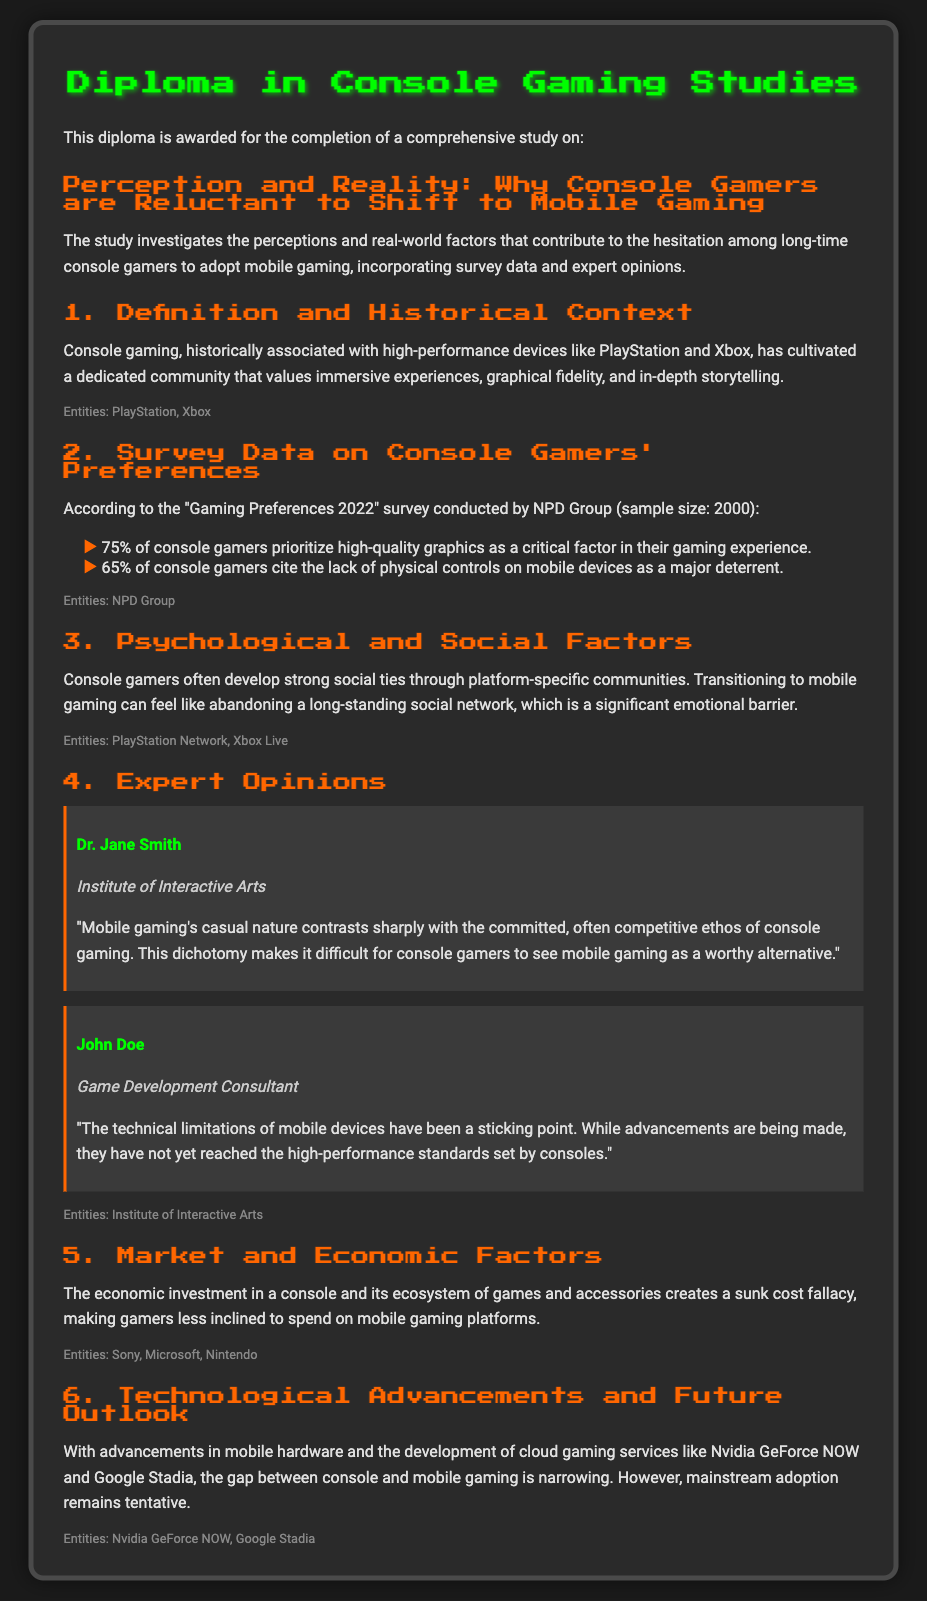what percentage of console gamers prioritize high-quality graphics? The survey data indicates that 75% of console gamers prioritize high-quality graphics as a critical factor in their gaming experience.
Answer: 75% who conducted the "Gaming Preferences 2022" survey? The document states that the survey was conducted by the NPD Group.
Answer: NPD Group what is a major deterrent for 65% of console gamers regarding mobile gaming? According to the survey data, 65% of console gamers cite the lack of physical controls on mobile devices as a major deterrent.
Answer: lack of physical controls what is a significant emotional barrier for console gamers transitioning to mobile gaming? The document mentions that transitioning to mobile gaming can feel like abandoning a long-standing social network.
Answer: abandoning a long-standing social network who is affiliated with the Institute of Interactive Arts? The document identifies Dr. Jane Smith as associated with the Institute of Interactive Arts.
Answer: Dr. Jane Smith which economic factor contributes to console gamers' reluctance to adopt mobile gaming? The document states that the sunk cost fallacy from the economic investment in consoles and their ecosystems makes gamers less inclined to spend on mobile gaming platforms.
Answer: sunk cost fallacy what is the title of the diploma? The document clearly states the title of the diploma is "Diploma in Console Gaming Studies."
Answer: Diploma in Console Gaming Studies 